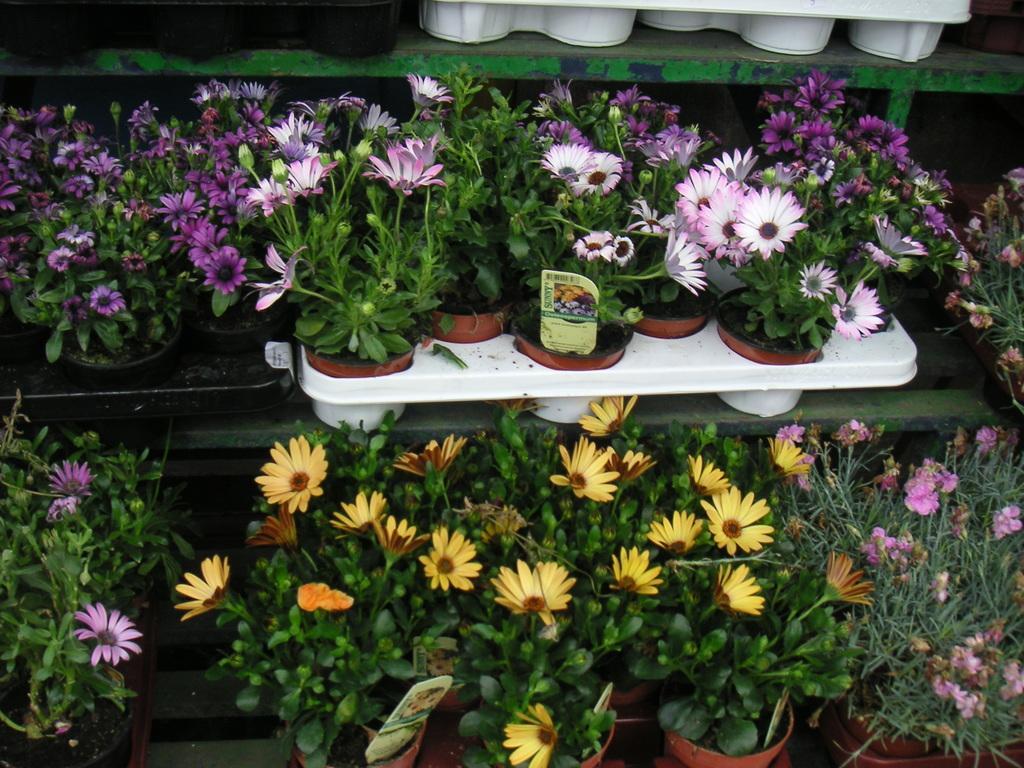Describe this image in one or two sentences. In this picture we can see shelves, here we can see house plants with flowers and cards. 